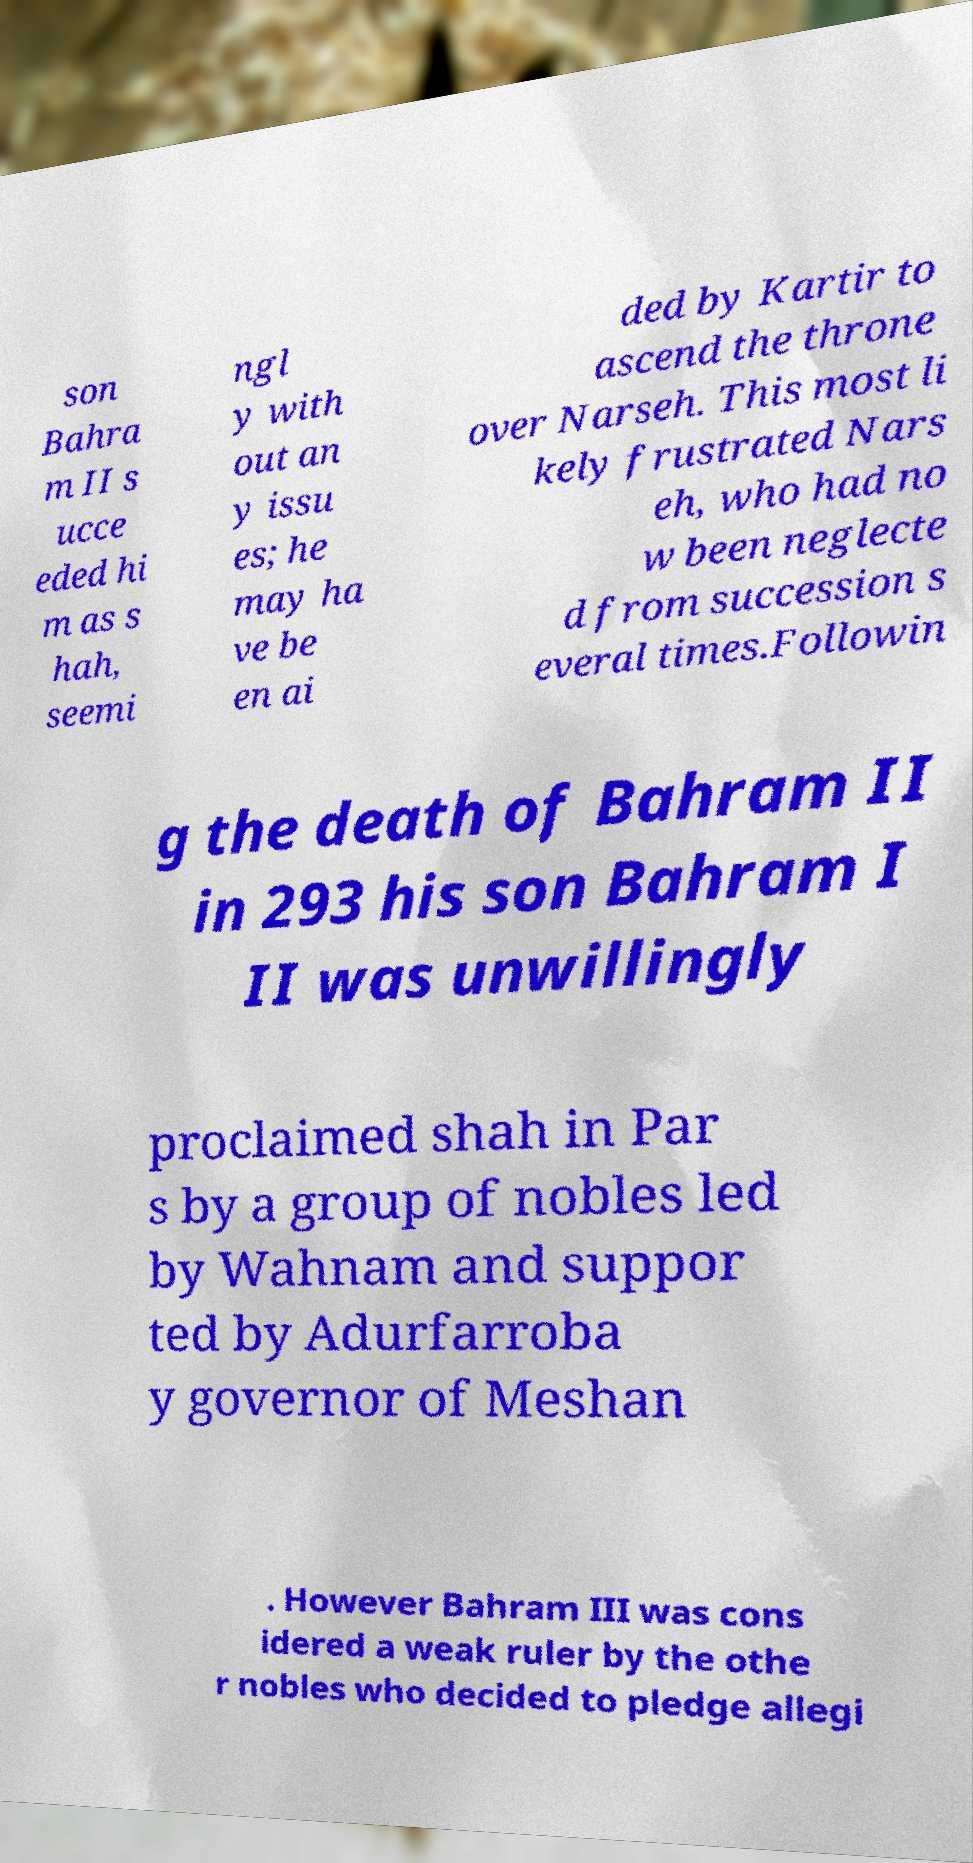Could you assist in decoding the text presented in this image and type it out clearly? son Bahra m II s ucce eded hi m as s hah, seemi ngl y with out an y issu es; he may ha ve be en ai ded by Kartir to ascend the throne over Narseh. This most li kely frustrated Nars eh, who had no w been neglecte d from succession s everal times.Followin g the death of Bahram II in 293 his son Bahram I II was unwillingly proclaimed shah in Par s by a group of nobles led by Wahnam and suppor ted by Adurfarroba y governor of Meshan . However Bahram III was cons idered a weak ruler by the othe r nobles who decided to pledge allegi 